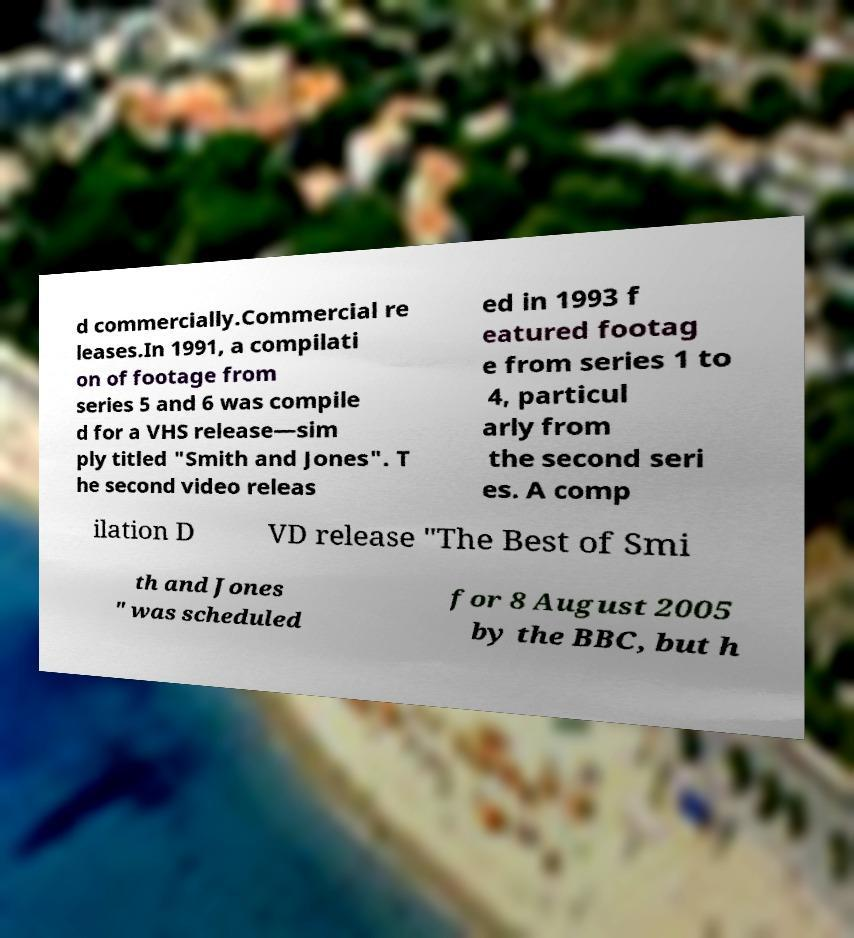I need the written content from this picture converted into text. Can you do that? d commercially.Commercial re leases.In 1991, a compilati on of footage from series 5 and 6 was compile d for a VHS release—sim ply titled "Smith and Jones". T he second video releas ed in 1993 f eatured footag e from series 1 to 4, particul arly from the second seri es. A comp ilation D VD release "The Best of Smi th and Jones " was scheduled for 8 August 2005 by the BBC, but h 